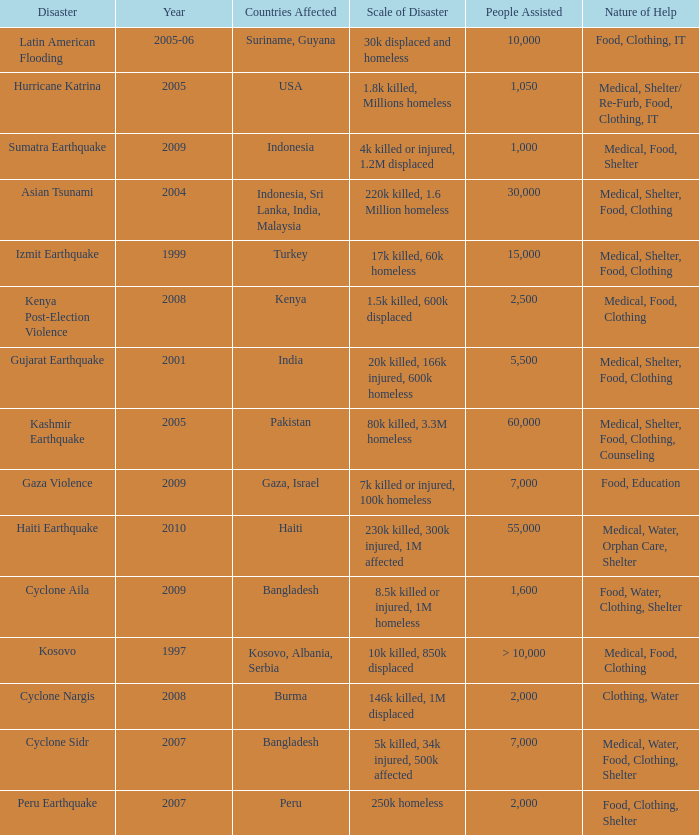Which year did USA undergo a disaster? 2005.0. 